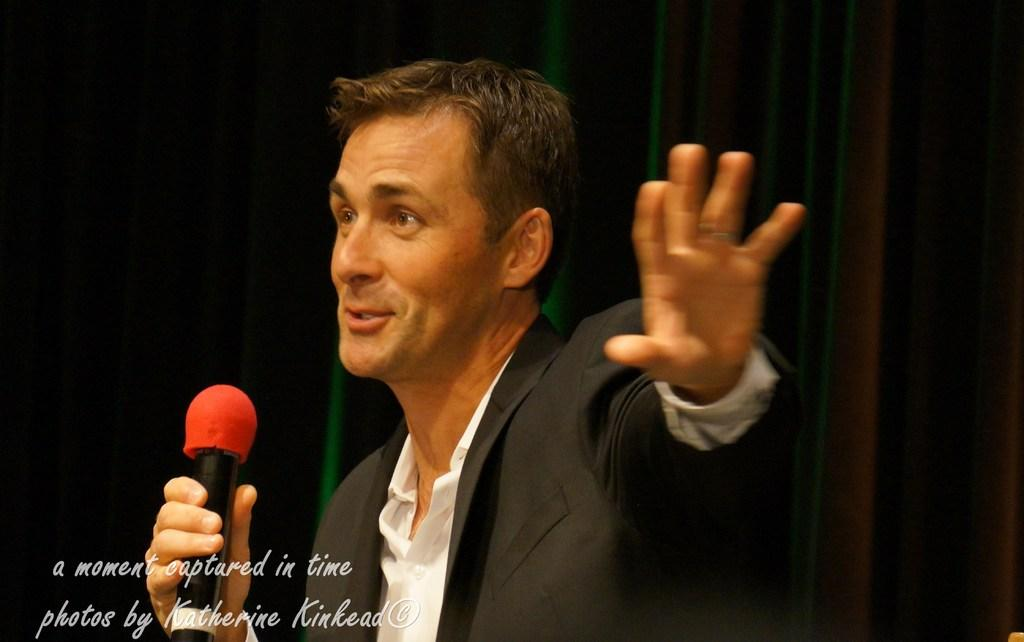What is the person in the image doing? The person is holding a microphone in the image. What can be inferred about the context of the image? The image is part of a collection titled "Moments Captured in Time" by Katherine Kincaid, suggesting that it is a candid or spontaneous moment. How many ants are crawling on the microphone in the image? There are no ants visible in the image, so there are no ants crawling on the microphone. 